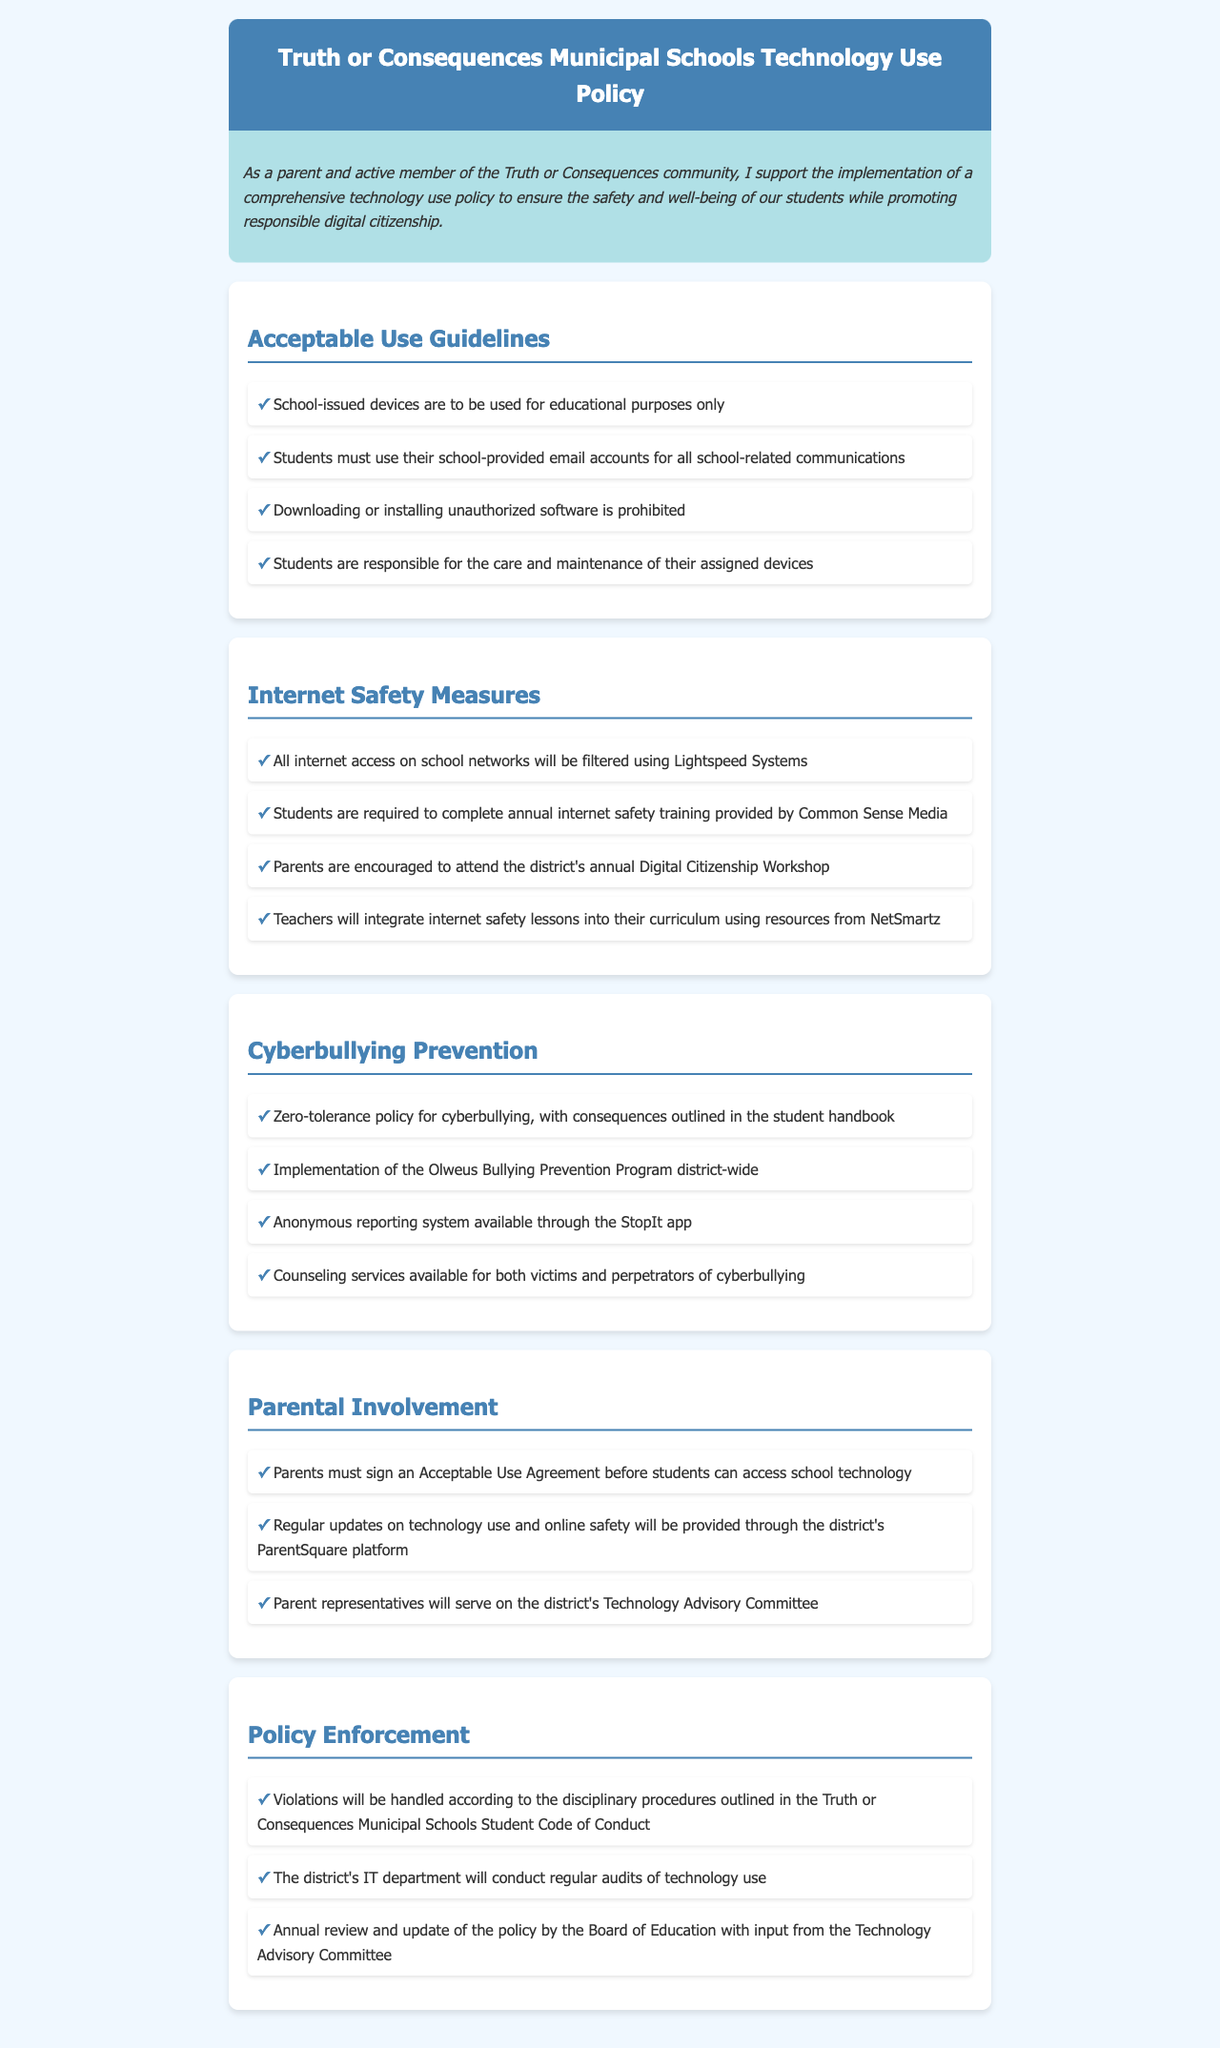What is the title of the document? The title of the document is presented in the header section, which indicates its purpose.
Answer: Truth or Consequences Municipal Schools Technology Use Policy What filtering system is used for internet access? The document specifies that all internet access will be filtered, naming the specific system employed for this purpose.
Answer: Lightspeed Systems What program is implemented district-wide for bullying prevention? The document states a specific program dedicated to bullying prevention in the district, as a measure to address cyberbullying.
Answer: Olweus Bullying Prevention Program How often must students complete internet safety training? The document outlines the frequency of training that students are required to complete regarding internet safety for their protection.
Answer: Annually What should parents sign before their child can access school technology? The document specifies a particular agreement that parents need to sign as a prerequisite for technology access for their children.
Answer: Acceptable Use Agreement What system is available for anonymous reporting of cyberbullying? The document mentions a specific app that allows for anonymous reporting of cyberbullying incidents.
Answer: StopIt app What is the consequence of cyberbullying according to the policy? The document indicates the seriousness of cyberbullying and the corresponding response outlined in the student handbook.
Answer: Zero-tolerance policy Which training provider is mentioned for internet safety education? The document names an organization that provides the mandatory training for students in internet safety.
Answer: Common Sense Media 